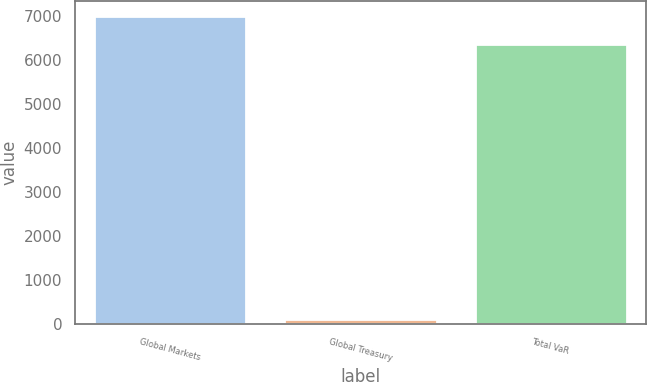<chart> <loc_0><loc_0><loc_500><loc_500><bar_chart><fcel>Global Markets<fcel>Global Treasury<fcel>Total VaR<nl><fcel>6989.9<fcel>97<fcel>6361<nl></chart> 